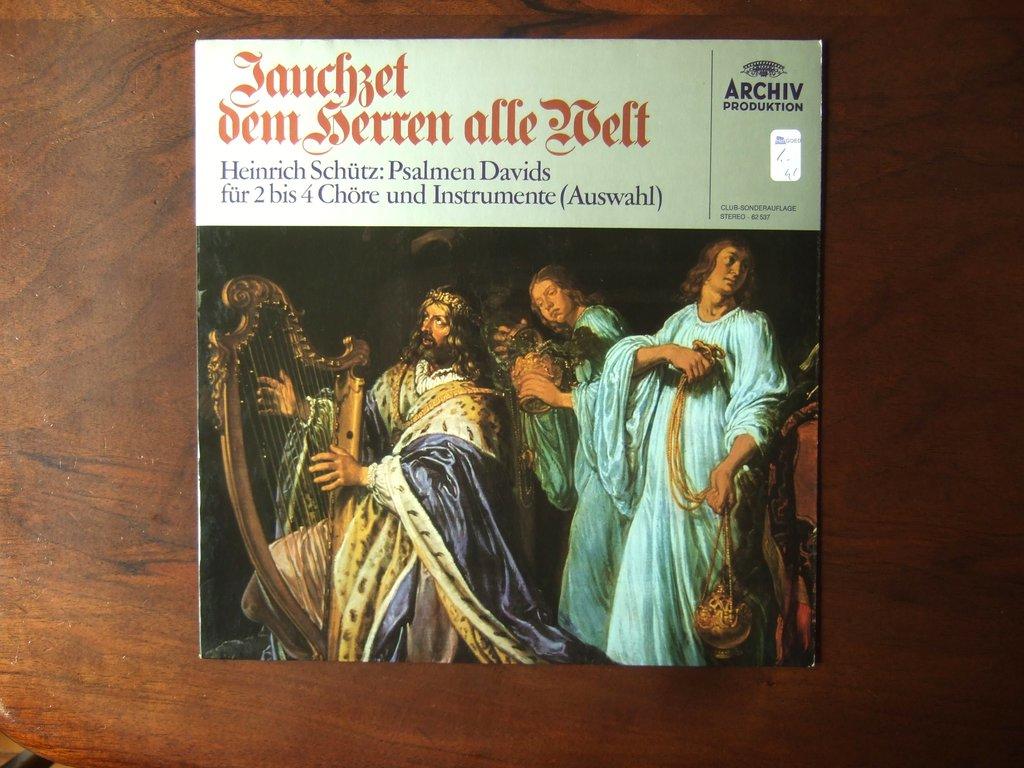Which production company is this by?
Offer a terse response. Archiv. 